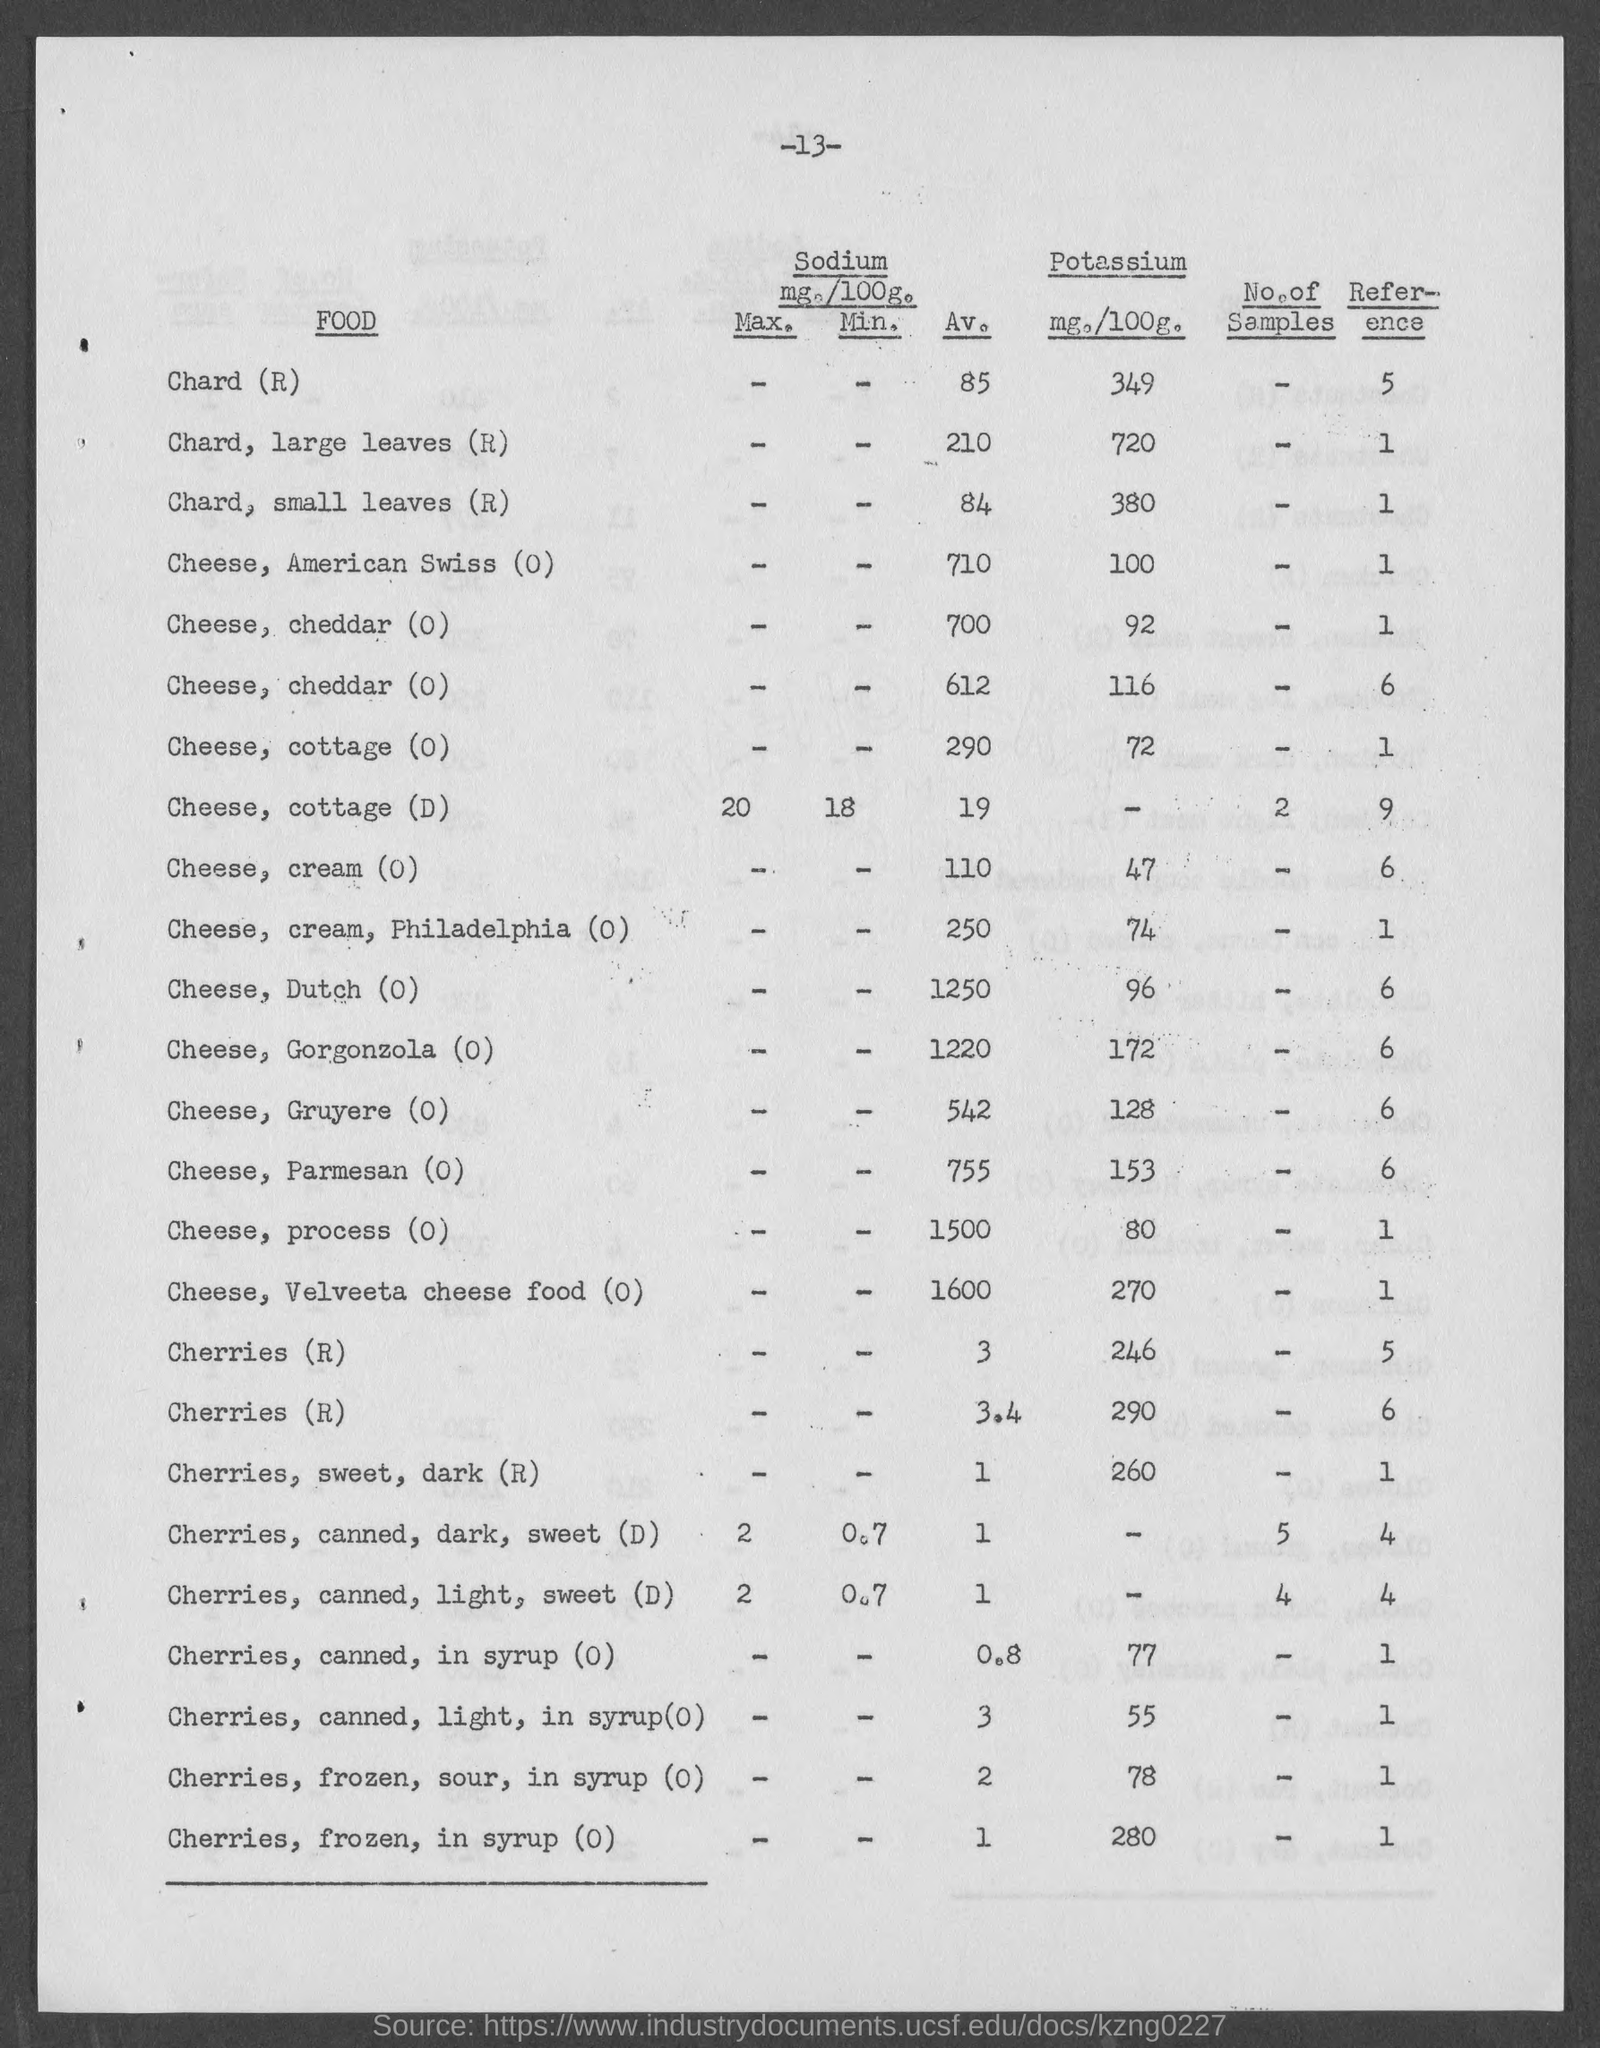The average amount of sodium present in cheese, velveeta cheese food?
Provide a succinct answer. 1600. 